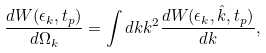Convert formula to latex. <formula><loc_0><loc_0><loc_500><loc_500>\frac { d W ( \epsilon _ { k } , t _ { p } ) } { d \Omega _ { k } } = \int d k k ^ { 2 } \frac { d W ( \epsilon _ { k } , \hat { k } , t _ { p } ) } { d { k } } ,</formula> 